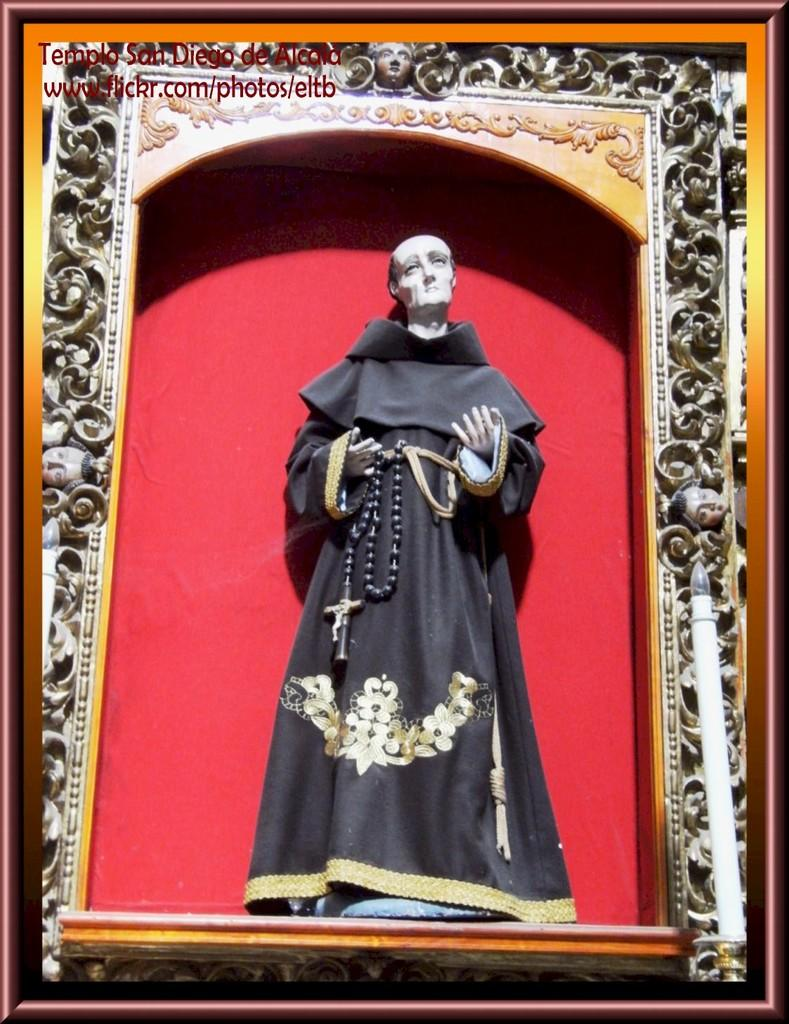What object in the image is typically used for displaying photos? There is a photo frame in the image. What type of artistic creation can be seen in the image? There is a sculpture in the image. What chess piece is depicted in the sculpture in the image? There is no chess piece depicted in the sculpture in the image. What type of caption is written on the photo frame in the image? There is no caption written on the photo frame in the image. 